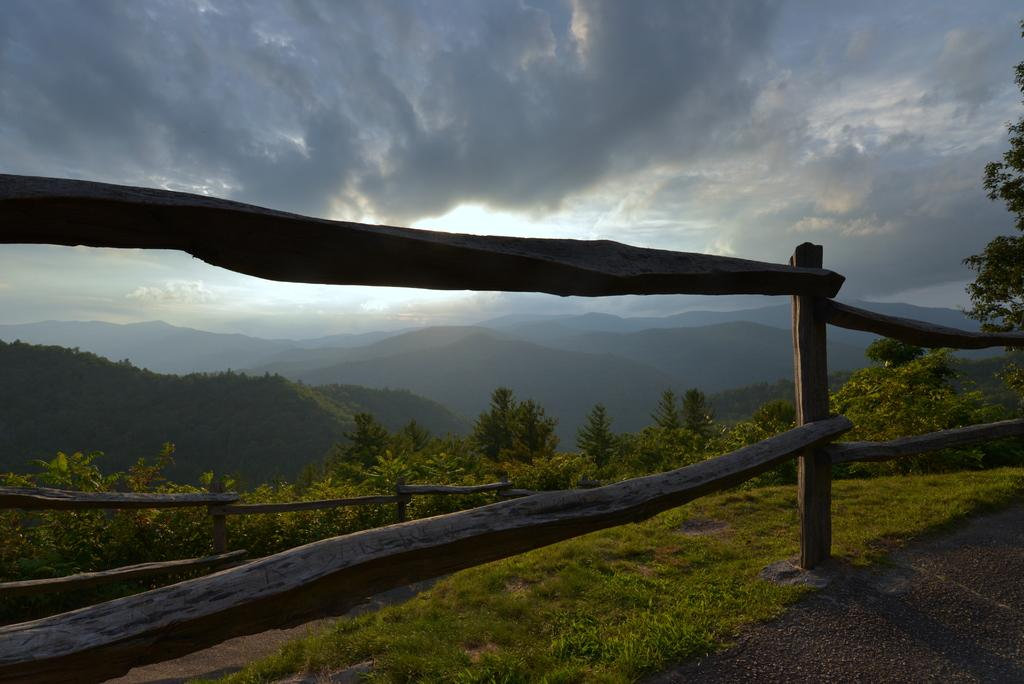What type of fence is present in the image? There is a wooden fence in the image. What can be seen in the foreground of the image? There are many trees in the image. What is visible in the distance in the image? There are mountains visible in the background of the image. What else can be seen in the background of the image? There are clouds and the sky visible in the background of the image. What type of bread can be seen in the image? There is no bread present in the image. 